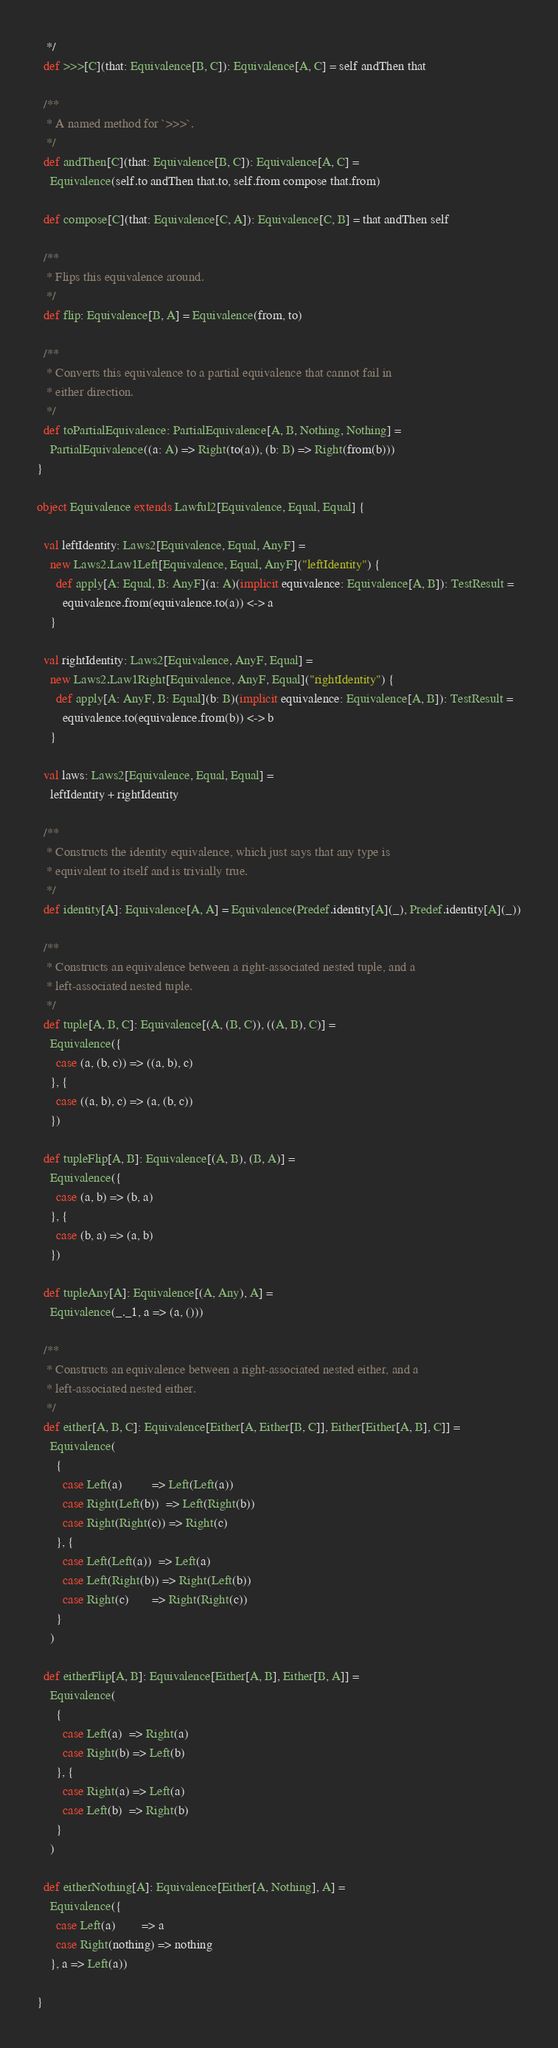Convert code to text. <code><loc_0><loc_0><loc_500><loc_500><_Scala_>   */
  def >>>[C](that: Equivalence[B, C]): Equivalence[A, C] = self andThen that

  /**
   * A named method for `>>>`.
   */
  def andThen[C](that: Equivalence[B, C]): Equivalence[A, C] =
    Equivalence(self.to andThen that.to, self.from compose that.from)

  def compose[C](that: Equivalence[C, A]): Equivalence[C, B] = that andThen self

  /**
   * Flips this equivalence around.
   */
  def flip: Equivalence[B, A] = Equivalence(from, to)

  /**
   * Converts this equivalence to a partial equivalence that cannot fail in
   * either direction.
   */
  def toPartialEquivalence: PartialEquivalence[A, B, Nothing, Nothing] =
    PartialEquivalence((a: A) => Right(to(a)), (b: B) => Right(from(b)))
}

object Equivalence extends Lawful2[Equivalence, Equal, Equal] {

  val leftIdentity: Laws2[Equivalence, Equal, AnyF] =
    new Laws2.Law1Left[Equivalence, Equal, AnyF]("leftIdentity") {
      def apply[A: Equal, B: AnyF](a: A)(implicit equivalence: Equivalence[A, B]): TestResult =
        equivalence.from(equivalence.to(a)) <-> a
    }

  val rightIdentity: Laws2[Equivalence, AnyF, Equal] =
    new Laws2.Law1Right[Equivalence, AnyF, Equal]("rightIdentity") {
      def apply[A: AnyF, B: Equal](b: B)(implicit equivalence: Equivalence[A, B]): TestResult =
        equivalence.to(equivalence.from(b)) <-> b
    }

  val laws: Laws2[Equivalence, Equal, Equal] =
    leftIdentity + rightIdentity

  /**
   * Constructs the identity equivalence, which just says that any type is
   * equivalent to itself and is trivially true.
   */
  def identity[A]: Equivalence[A, A] = Equivalence(Predef.identity[A](_), Predef.identity[A](_))

  /**
   * Constructs an equivalence between a right-associated nested tuple, and a
   * left-associated nested tuple.
   */
  def tuple[A, B, C]: Equivalence[(A, (B, C)), ((A, B), C)] =
    Equivalence({
      case (a, (b, c)) => ((a, b), c)
    }, {
      case ((a, b), c) => (a, (b, c))
    })

  def tupleFlip[A, B]: Equivalence[(A, B), (B, A)] =
    Equivalence({
      case (a, b) => (b, a)
    }, {
      case (b, a) => (a, b)
    })

  def tupleAny[A]: Equivalence[(A, Any), A] =
    Equivalence(_._1, a => (a, ()))

  /**
   * Constructs an equivalence between a right-associated nested either, and a
   * left-associated nested either.
   */
  def either[A, B, C]: Equivalence[Either[A, Either[B, C]], Either[Either[A, B], C]] =
    Equivalence(
      {
        case Left(a)         => Left(Left(a))
        case Right(Left(b))  => Left(Right(b))
        case Right(Right(c)) => Right(c)
      }, {
        case Left(Left(a))  => Left(a)
        case Left(Right(b)) => Right(Left(b))
        case Right(c)       => Right(Right(c))
      }
    )

  def eitherFlip[A, B]: Equivalence[Either[A, B], Either[B, A]] =
    Equivalence(
      {
        case Left(a)  => Right(a)
        case Right(b) => Left(b)
      }, {
        case Right(a) => Left(a)
        case Left(b)  => Right(b)
      }
    )

  def eitherNothing[A]: Equivalence[Either[A, Nothing], A] =
    Equivalence({
      case Left(a)        => a
      case Right(nothing) => nothing
    }, a => Left(a))

}
</code> 